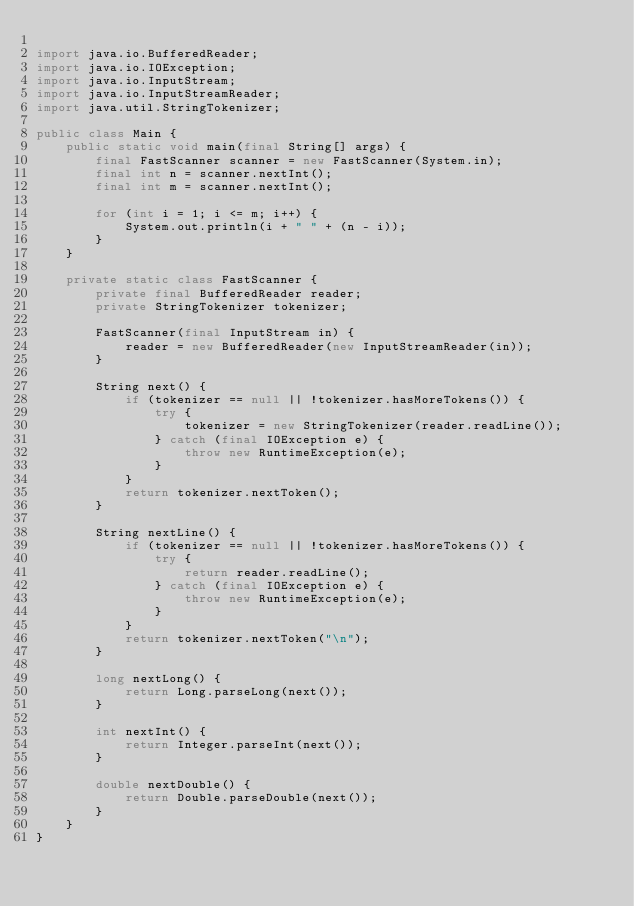Convert code to text. <code><loc_0><loc_0><loc_500><loc_500><_Java_>
import java.io.BufferedReader;
import java.io.IOException;
import java.io.InputStream;
import java.io.InputStreamReader;
import java.util.StringTokenizer;

public class Main {
    public static void main(final String[] args) {
        final FastScanner scanner = new FastScanner(System.in);
        final int n = scanner.nextInt();
        final int m = scanner.nextInt();
        
        for (int i = 1; i <= m; i++) {
            System.out.println(i + " " + (n - i));
        }
    }

    private static class FastScanner {
        private final BufferedReader reader;
        private StringTokenizer tokenizer;

        FastScanner(final InputStream in) {
            reader = new BufferedReader(new InputStreamReader(in));
        }

        String next() {
            if (tokenizer == null || !tokenizer.hasMoreTokens()) {
                try {
                    tokenizer = new StringTokenizer(reader.readLine());
                } catch (final IOException e) {
                    throw new RuntimeException(e);
                }
            }
            return tokenizer.nextToken();
        }

        String nextLine() {
            if (tokenizer == null || !tokenizer.hasMoreTokens()) {
                try {
                    return reader.readLine();
                } catch (final IOException e) {
                    throw new RuntimeException(e);
                }
            }
            return tokenizer.nextToken("\n");
        }

        long nextLong() {
            return Long.parseLong(next());
        }

        int nextInt() {
            return Integer.parseInt(next());
        }

        double nextDouble() {
            return Double.parseDouble(next());
        }
    }
}
</code> 